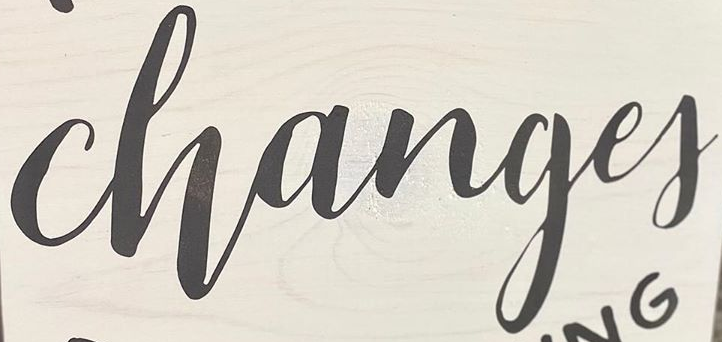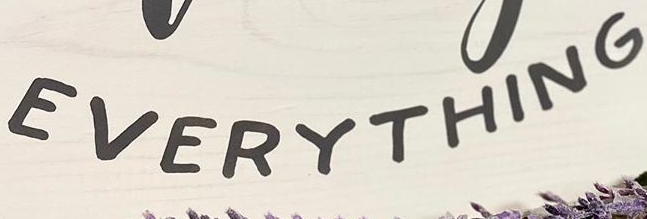Transcribe the words shown in these images in order, separated by a semicolon. Changef; EVERYTHING 